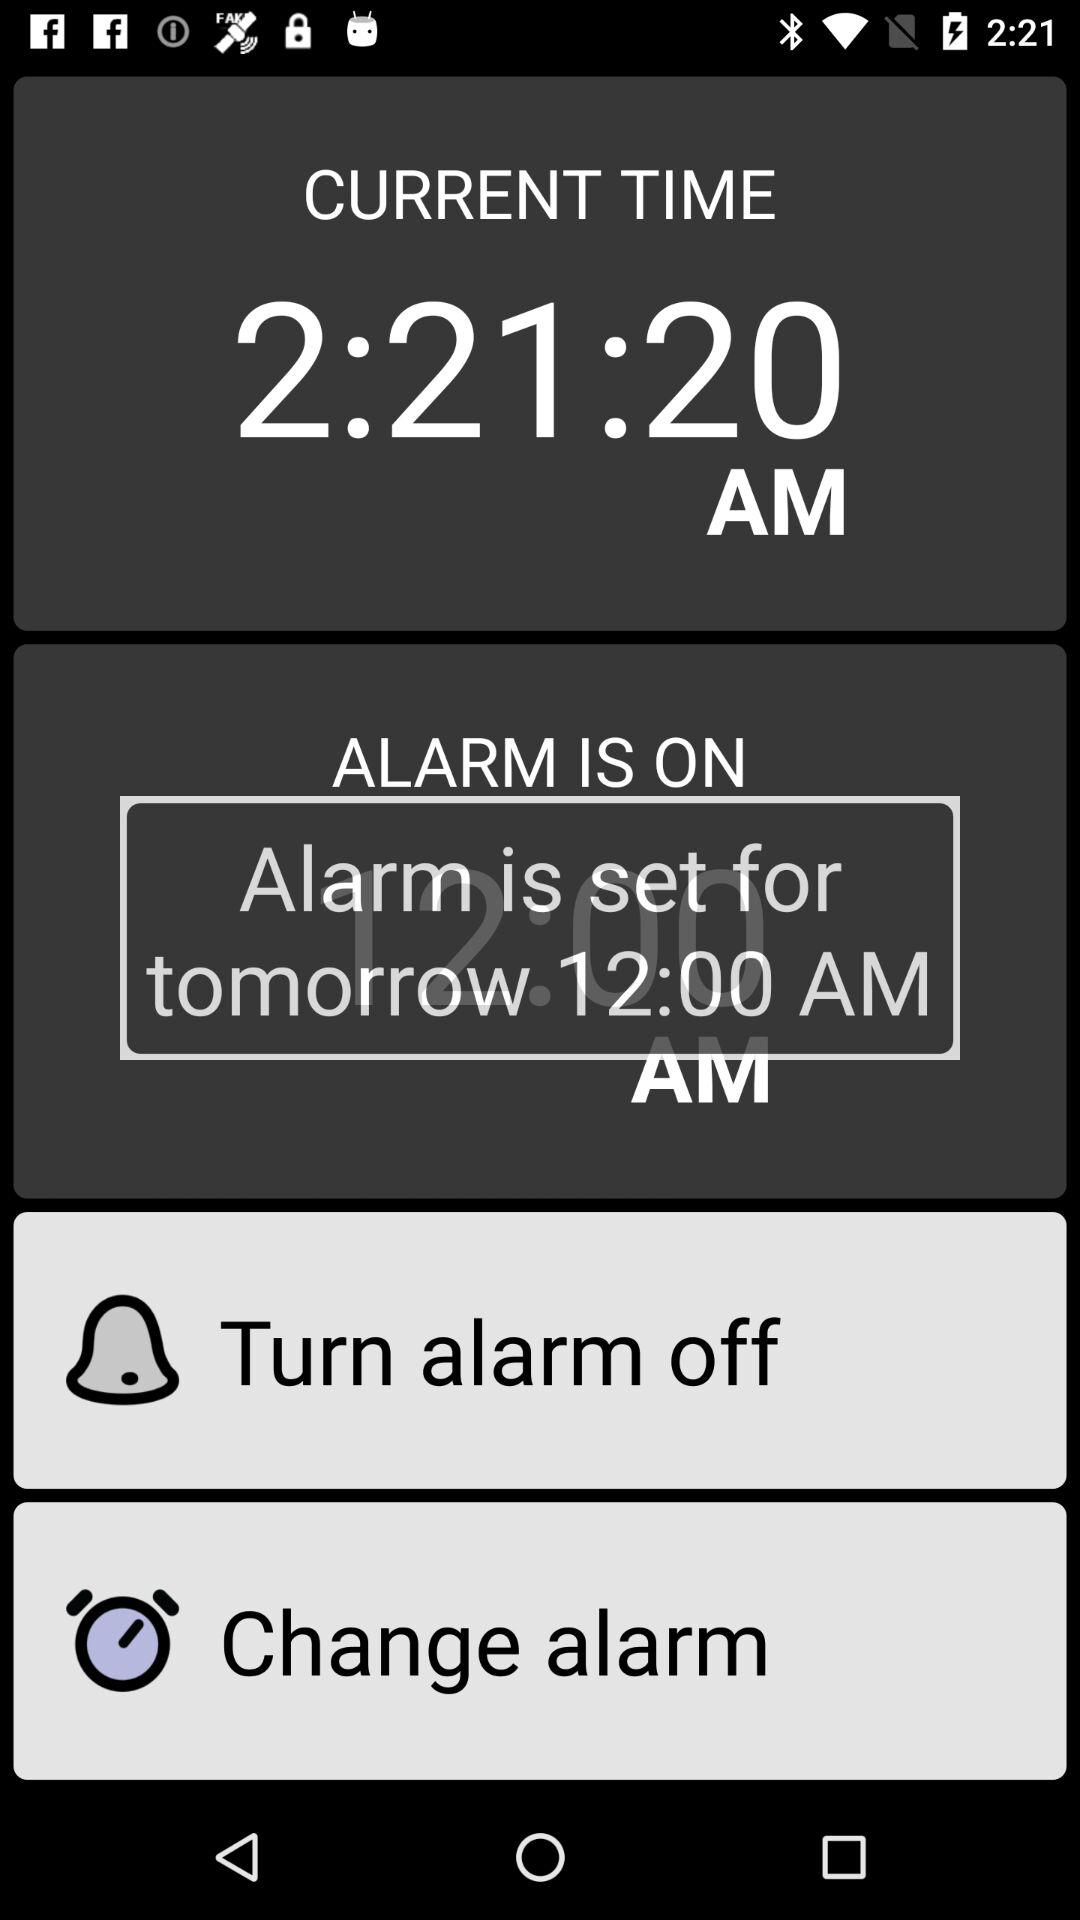How many hours before the alarm is set?
Answer the question using a single word or phrase. 12 